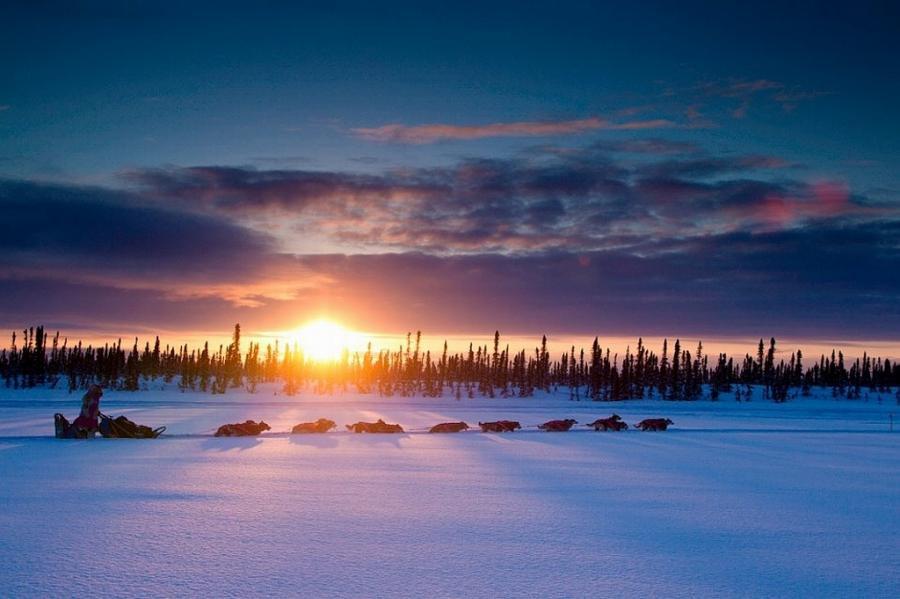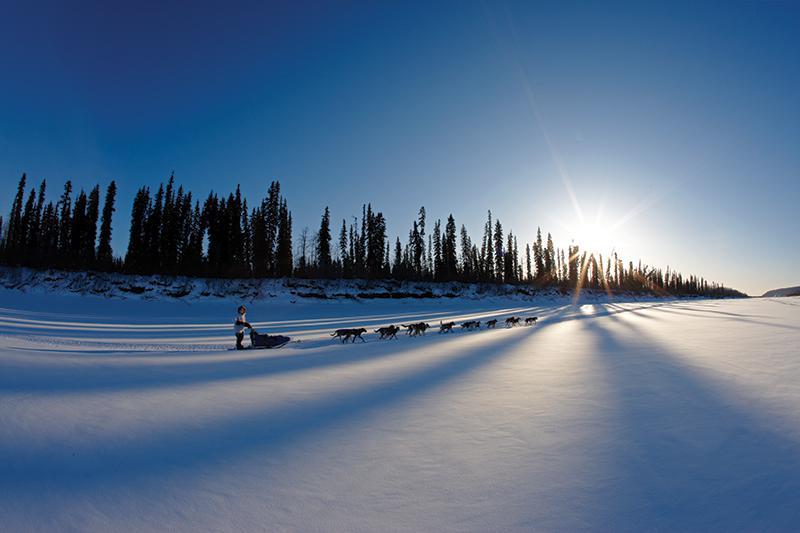The first image is the image on the left, the second image is the image on the right. Analyze the images presented: Is the assertion "Tall trees but no tall hills line the horizon in both images of sled dogs moving across the snow, and at least one image shows the sun shining above the trees." valid? Answer yes or no. Yes. The first image is the image on the left, the second image is the image on the right. For the images shown, is this caption "The sun gives off a soft glow behind the clouds in at least one of the images." true? Answer yes or no. Yes. 